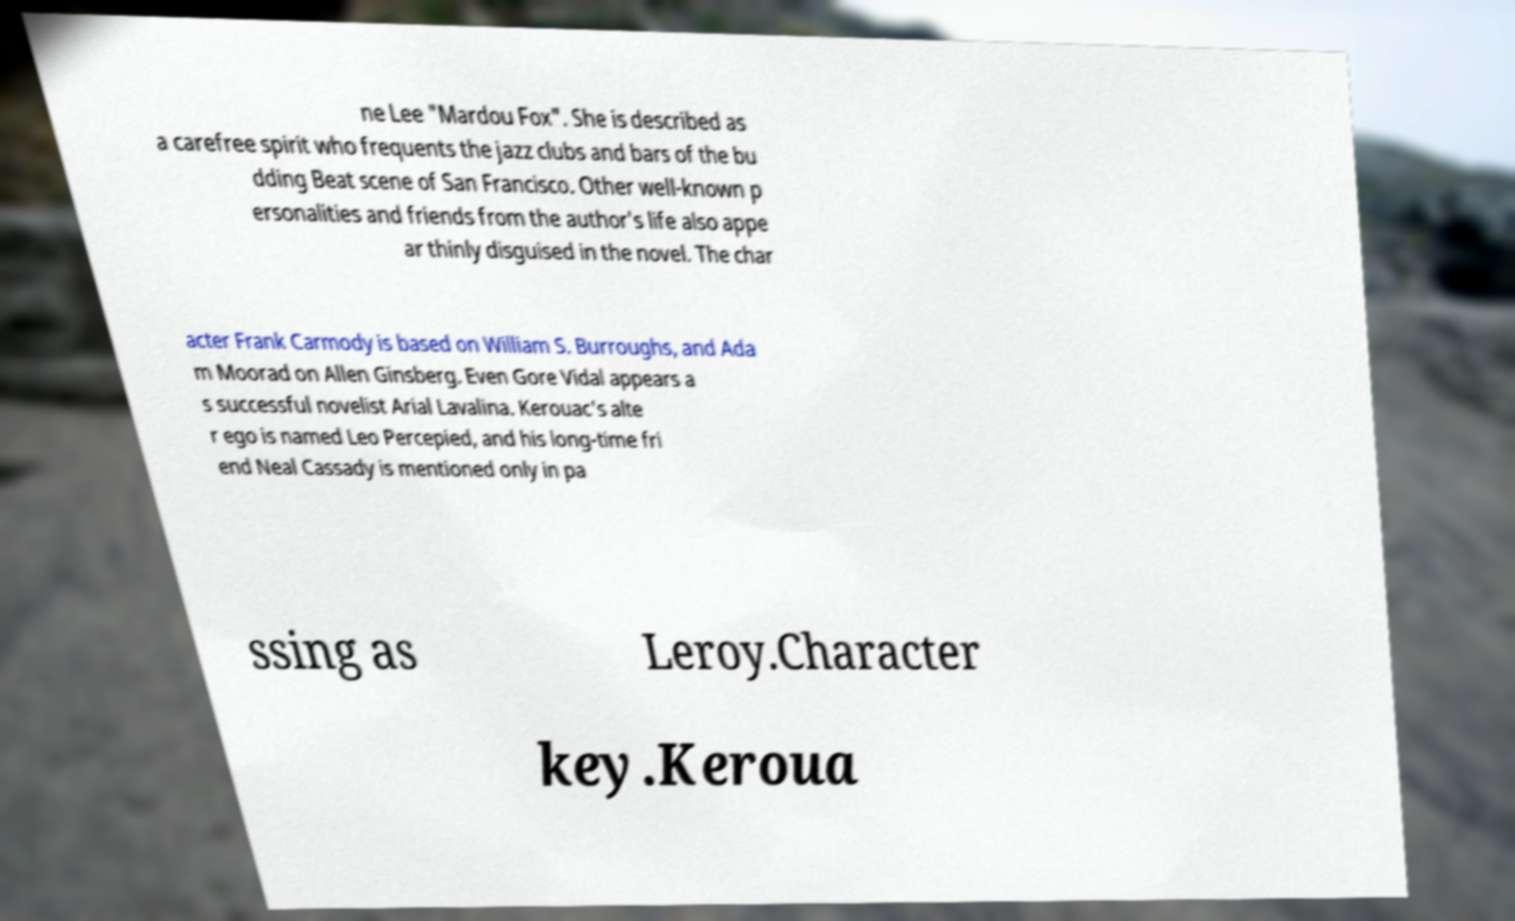Could you extract and type out the text from this image? ne Lee "Mardou Fox". She is described as a carefree spirit who frequents the jazz clubs and bars of the bu dding Beat scene of San Francisco. Other well-known p ersonalities and friends from the author's life also appe ar thinly disguised in the novel. The char acter Frank Carmody is based on William S. Burroughs, and Ada m Moorad on Allen Ginsberg. Even Gore Vidal appears a s successful novelist Arial Lavalina. Kerouac's alte r ego is named Leo Percepied, and his long-time fri end Neal Cassady is mentioned only in pa ssing as Leroy.Character key.Keroua 